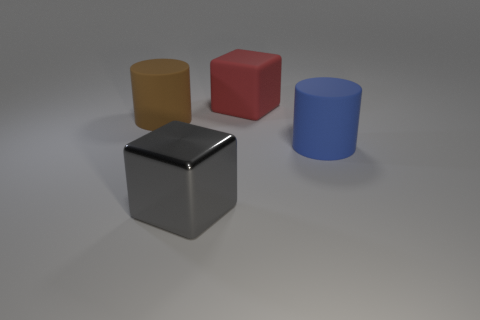There is a large rubber object in front of the big cylinder behind the big blue cylinder; what shape is it?
Make the answer very short. Cylinder. Are there any other things that have the same material as the gray cube?
Offer a terse response. No. What is the shape of the big red thing?
Offer a terse response. Cube. Are there the same number of large cubes that are left of the large metallic cube and shiny blocks that are on the right side of the blue thing?
Your answer should be very brief. Yes. What is the large object that is behind the metallic thing and in front of the brown cylinder made of?
Make the answer very short. Rubber. How many other things are there of the same color as the metal block?
Your answer should be compact. 0. Is the number of big matte things behind the large brown rubber thing greater than the number of tiny red blocks?
Provide a short and direct response. Yes. What color is the cylinder in front of the cylinder behind the large blue rubber cylinder that is right of the big brown cylinder?
Your answer should be very brief. Blue. Is the gray object made of the same material as the blue cylinder?
Your answer should be compact. No. Are there any other gray metal blocks of the same size as the gray block?
Ensure brevity in your answer.  No. 